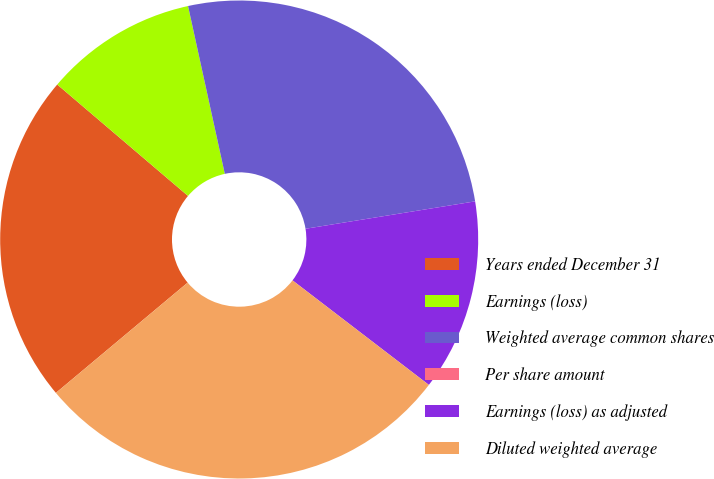Convert chart. <chart><loc_0><loc_0><loc_500><loc_500><pie_chart><fcel>Years ended December 31<fcel>Earnings (loss)<fcel>Weighted average common shares<fcel>Per share amount<fcel>Earnings (loss) as adjusted<fcel>Diluted weighted average<nl><fcel>22.32%<fcel>10.34%<fcel>25.88%<fcel>0.0%<fcel>12.96%<fcel>28.5%<nl></chart> 